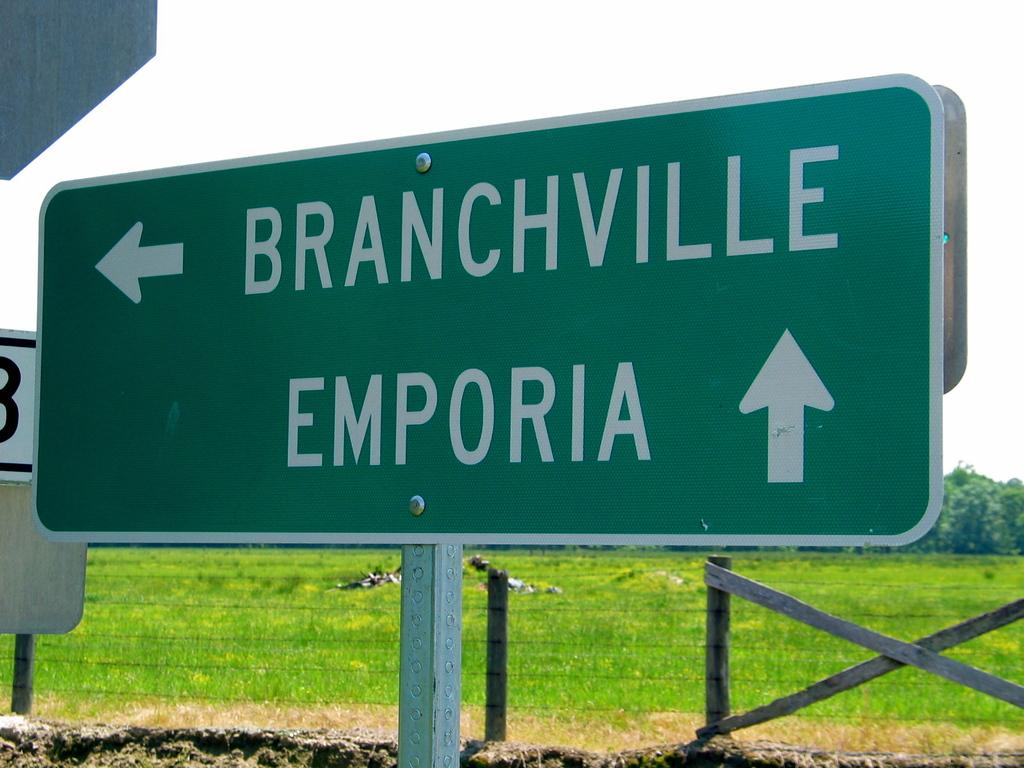<image>
Render a clear and concise summary of the photo. A sign directs you to Branchville to the left and Emporia to the right. 